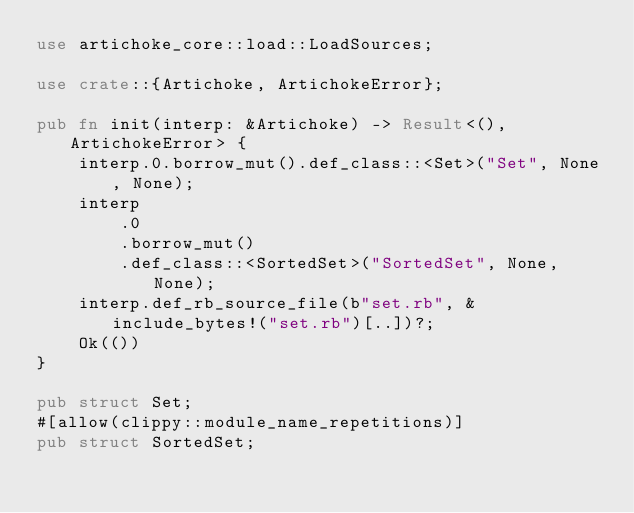Convert code to text. <code><loc_0><loc_0><loc_500><loc_500><_Rust_>use artichoke_core::load::LoadSources;

use crate::{Artichoke, ArtichokeError};

pub fn init(interp: &Artichoke) -> Result<(), ArtichokeError> {
    interp.0.borrow_mut().def_class::<Set>("Set", None, None);
    interp
        .0
        .borrow_mut()
        .def_class::<SortedSet>("SortedSet", None, None);
    interp.def_rb_source_file(b"set.rb", &include_bytes!("set.rb")[..])?;
    Ok(())
}

pub struct Set;
#[allow(clippy::module_name_repetitions)]
pub struct SortedSet;
</code> 